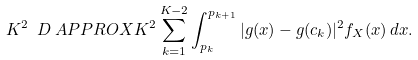<formula> <loc_0><loc_0><loc_500><loc_500>K ^ { 2 } \ D & \ A P P R O X K ^ { 2 } \sum _ { k = 1 } ^ { K - 2 } \int _ { p _ { k } } ^ { p _ { k + 1 } } | g ( x ) - g ( c _ { k } ) | ^ { 2 } f _ { X } ( x ) \, d x .</formula> 